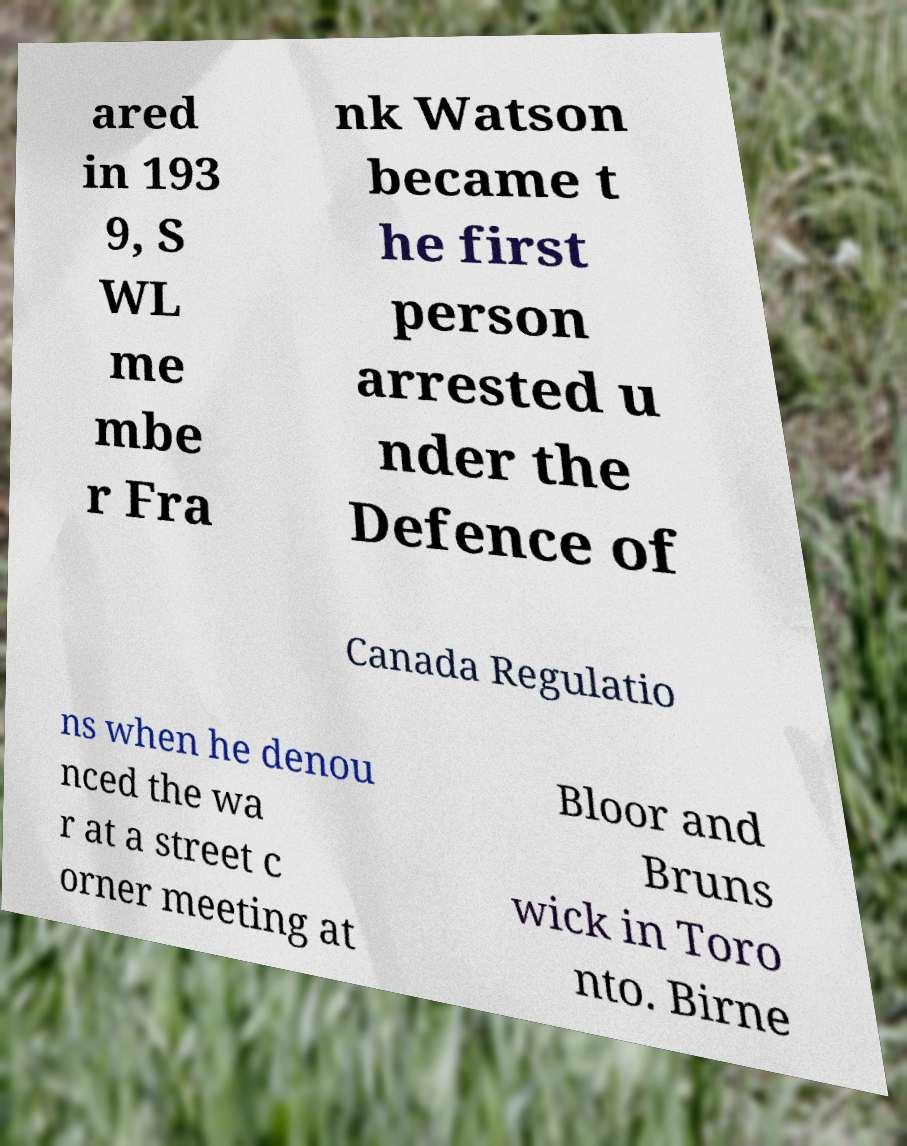For documentation purposes, I need the text within this image transcribed. Could you provide that? ared in 193 9, S WL me mbe r Fra nk Watson became t he first person arrested u nder the Defence of Canada Regulatio ns when he denou nced the wa r at a street c orner meeting at Bloor and Bruns wick in Toro nto. Birne 